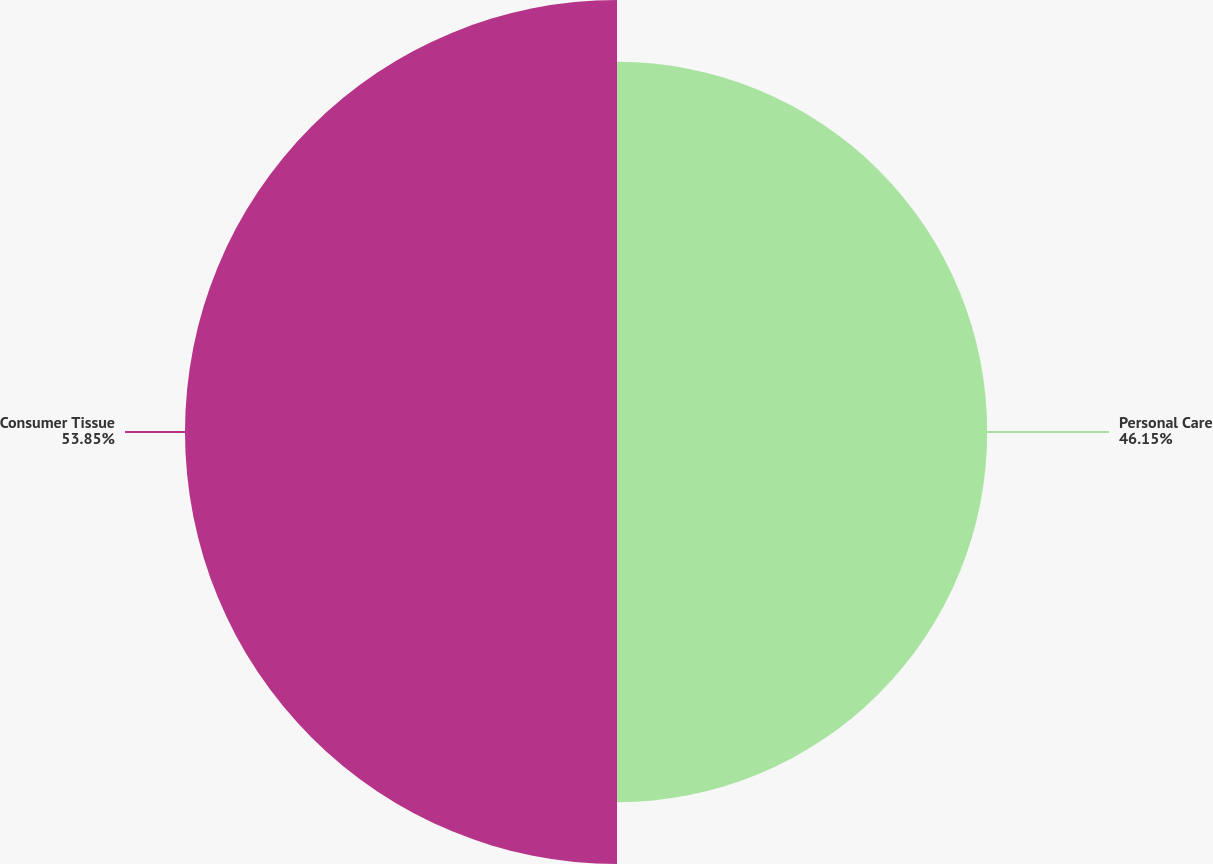<chart> <loc_0><loc_0><loc_500><loc_500><pie_chart><fcel>Personal Care<fcel>Consumer Tissue<nl><fcel>46.15%<fcel>53.85%<nl></chart> 